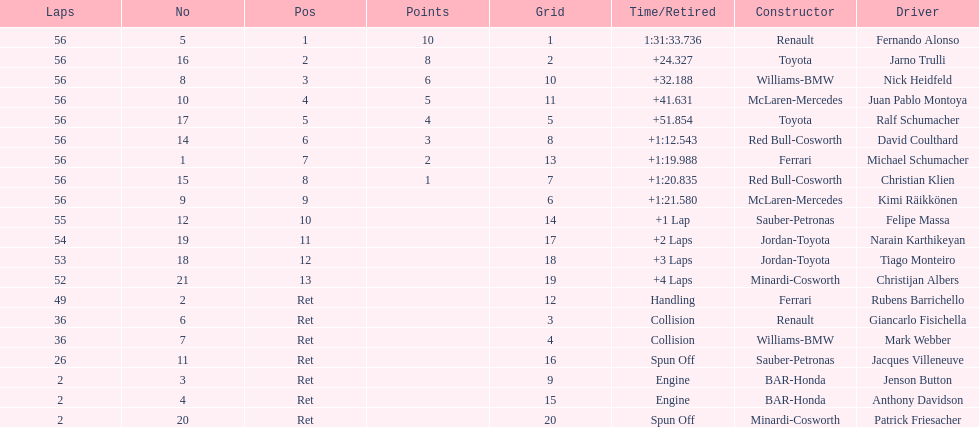How many drivers were retired before the race could end? 7. 